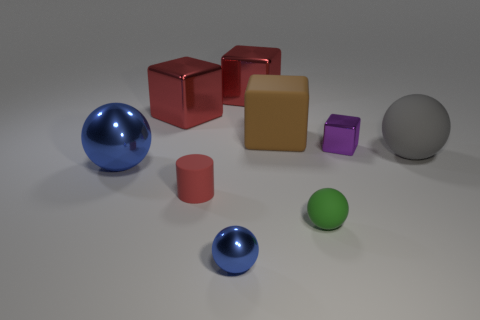What is the material of the large ball that is the same color as the small metallic sphere?
Provide a short and direct response. Metal. Is there anything else that has the same shape as the red matte object?
Your answer should be very brief. No. The big shiny thing that is behind the big red cube to the left of the large shiny object to the right of the red matte object is what color?
Keep it short and to the point. Red. What number of tiny objects are either blue blocks or green spheres?
Provide a short and direct response. 1. Are there the same number of big spheres that are right of the big brown matte cube and yellow metal balls?
Ensure brevity in your answer.  No. Are there any small green objects to the left of the big matte ball?
Give a very brief answer. Yes. What number of rubber objects are big brown blocks or red cylinders?
Your response must be concise. 2. There is a cylinder; how many things are in front of it?
Your answer should be compact. 2. Are there any cyan metal objects of the same size as the brown cube?
Your response must be concise. No. Is there a small rubber thing that has the same color as the large metallic sphere?
Keep it short and to the point. No. 